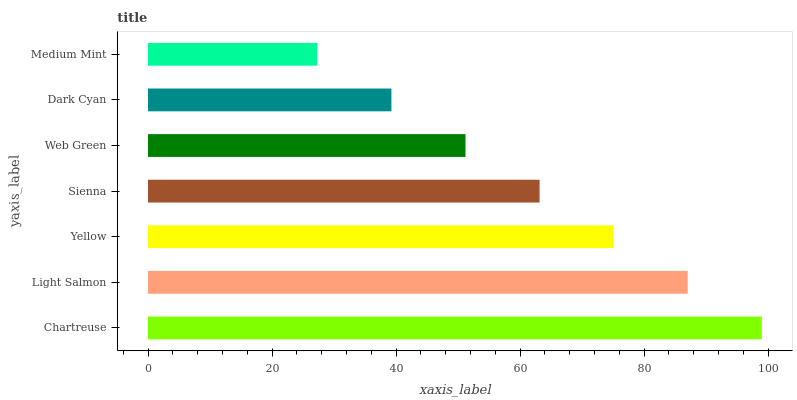Is Medium Mint the minimum?
Answer yes or no. Yes. Is Chartreuse the maximum?
Answer yes or no. Yes. Is Light Salmon the minimum?
Answer yes or no. No. Is Light Salmon the maximum?
Answer yes or no. No. Is Chartreuse greater than Light Salmon?
Answer yes or no. Yes. Is Light Salmon less than Chartreuse?
Answer yes or no. Yes. Is Light Salmon greater than Chartreuse?
Answer yes or no. No. Is Chartreuse less than Light Salmon?
Answer yes or no. No. Is Sienna the high median?
Answer yes or no. Yes. Is Sienna the low median?
Answer yes or no. Yes. Is Medium Mint the high median?
Answer yes or no. No. Is Light Salmon the low median?
Answer yes or no. No. 